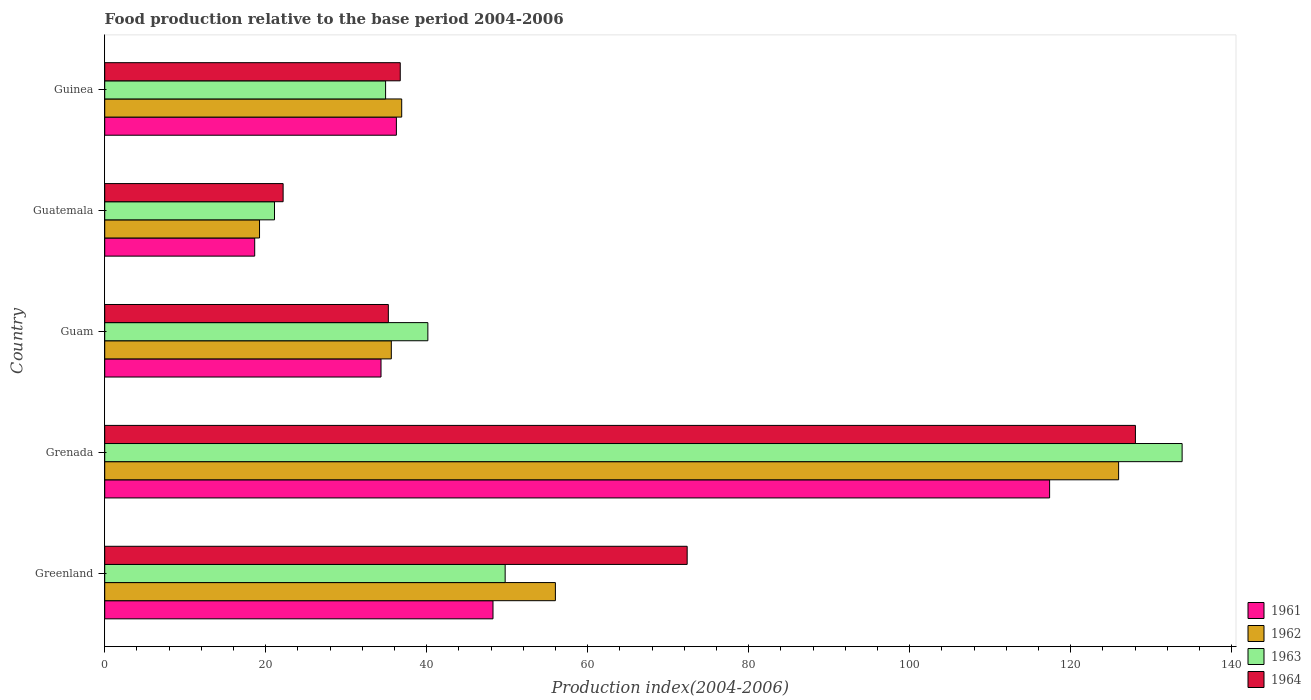How many different coloured bars are there?
Your response must be concise. 4. Are the number of bars per tick equal to the number of legend labels?
Your response must be concise. Yes. Are the number of bars on each tick of the Y-axis equal?
Your response must be concise. Yes. What is the label of the 1st group of bars from the top?
Your response must be concise. Guinea. What is the food production index in 1962 in Greenland?
Your answer should be very brief. 55.98. Across all countries, what is the maximum food production index in 1964?
Offer a terse response. 128.03. Across all countries, what is the minimum food production index in 1961?
Ensure brevity in your answer.  18.63. In which country was the food production index in 1962 maximum?
Make the answer very short. Grenada. In which country was the food production index in 1964 minimum?
Keep it short and to the point. Guatemala. What is the total food production index in 1964 in the graph?
Give a very brief answer. 294.48. What is the difference between the food production index in 1961 in Grenada and that in Guatemala?
Provide a succinct answer. 98.74. What is the difference between the food production index in 1961 in Greenland and the food production index in 1963 in Guam?
Give a very brief answer. 8.09. What is the average food production index in 1963 per country?
Ensure brevity in your answer.  55.94. What is the difference between the food production index in 1964 and food production index in 1962 in Grenada?
Ensure brevity in your answer.  2.09. What is the ratio of the food production index in 1964 in Grenada to that in Guam?
Your response must be concise. 3.63. Is the food production index in 1963 in Guam less than that in Guatemala?
Your answer should be compact. No. What is the difference between the highest and the second highest food production index in 1963?
Your answer should be very brief. 84.09. What is the difference between the highest and the lowest food production index in 1962?
Keep it short and to the point. 106.71. Is it the case that in every country, the sum of the food production index in 1964 and food production index in 1963 is greater than the sum of food production index in 1962 and food production index in 1961?
Your answer should be compact. No. What does the 2nd bar from the top in Grenada represents?
Keep it short and to the point. 1963. How many bars are there?
Provide a succinct answer. 20. How many countries are there in the graph?
Keep it short and to the point. 5. What is the difference between two consecutive major ticks on the X-axis?
Provide a succinct answer. 20. Are the values on the major ticks of X-axis written in scientific E-notation?
Give a very brief answer. No. Does the graph contain any zero values?
Offer a very short reply. No. Where does the legend appear in the graph?
Offer a terse response. Bottom right. What is the title of the graph?
Offer a terse response. Food production relative to the base period 2004-2006. What is the label or title of the X-axis?
Provide a succinct answer. Production index(2004-2006). What is the Production index(2004-2006) of 1961 in Greenland?
Offer a terse response. 48.23. What is the Production index(2004-2006) of 1962 in Greenland?
Your answer should be compact. 55.98. What is the Production index(2004-2006) in 1963 in Greenland?
Your answer should be very brief. 49.74. What is the Production index(2004-2006) of 1964 in Greenland?
Make the answer very short. 72.35. What is the Production index(2004-2006) in 1961 in Grenada?
Offer a terse response. 117.37. What is the Production index(2004-2006) in 1962 in Grenada?
Your answer should be very brief. 125.94. What is the Production index(2004-2006) of 1963 in Grenada?
Your answer should be very brief. 133.83. What is the Production index(2004-2006) in 1964 in Grenada?
Your response must be concise. 128.03. What is the Production index(2004-2006) of 1961 in Guam?
Provide a short and direct response. 34.32. What is the Production index(2004-2006) in 1962 in Guam?
Your answer should be very brief. 35.6. What is the Production index(2004-2006) of 1963 in Guam?
Your answer should be very brief. 40.14. What is the Production index(2004-2006) in 1964 in Guam?
Make the answer very short. 35.23. What is the Production index(2004-2006) of 1961 in Guatemala?
Provide a succinct answer. 18.63. What is the Production index(2004-2006) of 1962 in Guatemala?
Offer a very short reply. 19.23. What is the Production index(2004-2006) in 1963 in Guatemala?
Ensure brevity in your answer.  21.09. What is the Production index(2004-2006) of 1964 in Guatemala?
Offer a very short reply. 22.16. What is the Production index(2004-2006) in 1961 in Guinea?
Your answer should be compact. 36.23. What is the Production index(2004-2006) of 1962 in Guinea?
Your answer should be very brief. 36.89. What is the Production index(2004-2006) of 1963 in Guinea?
Provide a short and direct response. 34.89. What is the Production index(2004-2006) in 1964 in Guinea?
Your answer should be very brief. 36.71. Across all countries, what is the maximum Production index(2004-2006) in 1961?
Provide a succinct answer. 117.37. Across all countries, what is the maximum Production index(2004-2006) of 1962?
Keep it short and to the point. 125.94. Across all countries, what is the maximum Production index(2004-2006) in 1963?
Provide a short and direct response. 133.83. Across all countries, what is the maximum Production index(2004-2006) of 1964?
Keep it short and to the point. 128.03. Across all countries, what is the minimum Production index(2004-2006) of 1961?
Offer a very short reply. 18.63. Across all countries, what is the minimum Production index(2004-2006) in 1962?
Keep it short and to the point. 19.23. Across all countries, what is the minimum Production index(2004-2006) in 1963?
Your response must be concise. 21.09. Across all countries, what is the minimum Production index(2004-2006) of 1964?
Keep it short and to the point. 22.16. What is the total Production index(2004-2006) of 1961 in the graph?
Make the answer very short. 254.78. What is the total Production index(2004-2006) in 1962 in the graph?
Keep it short and to the point. 273.64. What is the total Production index(2004-2006) in 1963 in the graph?
Your answer should be very brief. 279.69. What is the total Production index(2004-2006) of 1964 in the graph?
Give a very brief answer. 294.48. What is the difference between the Production index(2004-2006) of 1961 in Greenland and that in Grenada?
Keep it short and to the point. -69.14. What is the difference between the Production index(2004-2006) in 1962 in Greenland and that in Grenada?
Offer a terse response. -69.96. What is the difference between the Production index(2004-2006) in 1963 in Greenland and that in Grenada?
Offer a terse response. -84.09. What is the difference between the Production index(2004-2006) of 1964 in Greenland and that in Grenada?
Offer a very short reply. -55.68. What is the difference between the Production index(2004-2006) of 1961 in Greenland and that in Guam?
Ensure brevity in your answer.  13.91. What is the difference between the Production index(2004-2006) of 1962 in Greenland and that in Guam?
Give a very brief answer. 20.38. What is the difference between the Production index(2004-2006) in 1964 in Greenland and that in Guam?
Make the answer very short. 37.12. What is the difference between the Production index(2004-2006) in 1961 in Greenland and that in Guatemala?
Your answer should be very brief. 29.6. What is the difference between the Production index(2004-2006) in 1962 in Greenland and that in Guatemala?
Ensure brevity in your answer.  36.75. What is the difference between the Production index(2004-2006) in 1963 in Greenland and that in Guatemala?
Make the answer very short. 28.65. What is the difference between the Production index(2004-2006) in 1964 in Greenland and that in Guatemala?
Give a very brief answer. 50.19. What is the difference between the Production index(2004-2006) in 1962 in Greenland and that in Guinea?
Offer a very short reply. 19.09. What is the difference between the Production index(2004-2006) of 1963 in Greenland and that in Guinea?
Offer a terse response. 14.85. What is the difference between the Production index(2004-2006) of 1964 in Greenland and that in Guinea?
Make the answer very short. 35.64. What is the difference between the Production index(2004-2006) of 1961 in Grenada and that in Guam?
Your response must be concise. 83.05. What is the difference between the Production index(2004-2006) of 1962 in Grenada and that in Guam?
Ensure brevity in your answer.  90.34. What is the difference between the Production index(2004-2006) in 1963 in Grenada and that in Guam?
Make the answer very short. 93.69. What is the difference between the Production index(2004-2006) of 1964 in Grenada and that in Guam?
Ensure brevity in your answer.  92.8. What is the difference between the Production index(2004-2006) in 1961 in Grenada and that in Guatemala?
Offer a terse response. 98.74. What is the difference between the Production index(2004-2006) of 1962 in Grenada and that in Guatemala?
Your answer should be very brief. 106.71. What is the difference between the Production index(2004-2006) in 1963 in Grenada and that in Guatemala?
Your answer should be compact. 112.74. What is the difference between the Production index(2004-2006) in 1964 in Grenada and that in Guatemala?
Give a very brief answer. 105.87. What is the difference between the Production index(2004-2006) of 1961 in Grenada and that in Guinea?
Give a very brief answer. 81.14. What is the difference between the Production index(2004-2006) of 1962 in Grenada and that in Guinea?
Keep it short and to the point. 89.05. What is the difference between the Production index(2004-2006) in 1963 in Grenada and that in Guinea?
Your answer should be very brief. 98.94. What is the difference between the Production index(2004-2006) in 1964 in Grenada and that in Guinea?
Offer a terse response. 91.32. What is the difference between the Production index(2004-2006) in 1961 in Guam and that in Guatemala?
Make the answer very short. 15.69. What is the difference between the Production index(2004-2006) in 1962 in Guam and that in Guatemala?
Make the answer very short. 16.37. What is the difference between the Production index(2004-2006) in 1963 in Guam and that in Guatemala?
Your response must be concise. 19.05. What is the difference between the Production index(2004-2006) of 1964 in Guam and that in Guatemala?
Give a very brief answer. 13.07. What is the difference between the Production index(2004-2006) in 1961 in Guam and that in Guinea?
Offer a terse response. -1.91. What is the difference between the Production index(2004-2006) in 1962 in Guam and that in Guinea?
Provide a short and direct response. -1.29. What is the difference between the Production index(2004-2006) of 1963 in Guam and that in Guinea?
Provide a succinct answer. 5.25. What is the difference between the Production index(2004-2006) of 1964 in Guam and that in Guinea?
Provide a short and direct response. -1.48. What is the difference between the Production index(2004-2006) in 1961 in Guatemala and that in Guinea?
Give a very brief answer. -17.6. What is the difference between the Production index(2004-2006) in 1962 in Guatemala and that in Guinea?
Provide a short and direct response. -17.66. What is the difference between the Production index(2004-2006) of 1963 in Guatemala and that in Guinea?
Ensure brevity in your answer.  -13.8. What is the difference between the Production index(2004-2006) of 1964 in Guatemala and that in Guinea?
Your response must be concise. -14.55. What is the difference between the Production index(2004-2006) in 1961 in Greenland and the Production index(2004-2006) in 1962 in Grenada?
Your answer should be compact. -77.71. What is the difference between the Production index(2004-2006) of 1961 in Greenland and the Production index(2004-2006) of 1963 in Grenada?
Offer a very short reply. -85.6. What is the difference between the Production index(2004-2006) in 1961 in Greenland and the Production index(2004-2006) in 1964 in Grenada?
Provide a succinct answer. -79.8. What is the difference between the Production index(2004-2006) of 1962 in Greenland and the Production index(2004-2006) of 1963 in Grenada?
Ensure brevity in your answer.  -77.85. What is the difference between the Production index(2004-2006) of 1962 in Greenland and the Production index(2004-2006) of 1964 in Grenada?
Offer a terse response. -72.05. What is the difference between the Production index(2004-2006) of 1963 in Greenland and the Production index(2004-2006) of 1964 in Grenada?
Ensure brevity in your answer.  -78.29. What is the difference between the Production index(2004-2006) in 1961 in Greenland and the Production index(2004-2006) in 1962 in Guam?
Provide a succinct answer. 12.63. What is the difference between the Production index(2004-2006) in 1961 in Greenland and the Production index(2004-2006) in 1963 in Guam?
Your answer should be very brief. 8.09. What is the difference between the Production index(2004-2006) of 1961 in Greenland and the Production index(2004-2006) of 1964 in Guam?
Your answer should be compact. 13. What is the difference between the Production index(2004-2006) in 1962 in Greenland and the Production index(2004-2006) in 1963 in Guam?
Provide a succinct answer. 15.84. What is the difference between the Production index(2004-2006) of 1962 in Greenland and the Production index(2004-2006) of 1964 in Guam?
Provide a short and direct response. 20.75. What is the difference between the Production index(2004-2006) in 1963 in Greenland and the Production index(2004-2006) in 1964 in Guam?
Provide a short and direct response. 14.51. What is the difference between the Production index(2004-2006) of 1961 in Greenland and the Production index(2004-2006) of 1962 in Guatemala?
Your answer should be compact. 29. What is the difference between the Production index(2004-2006) of 1961 in Greenland and the Production index(2004-2006) of 1963 in Guatemala?
Keep it short and to the point. 27.14. What is the difference between the Production index(2004-2006) of 1961 in Greenland and the Production index(2004-2006) of 1964 in Guatemala?
Make the answer very short. 26.07. What is the difference between the Production index(2004-2006) in 1962 in Greenland and the Production index(2004-2006) in 1963 in Guatemala?
Your response must be concise. 34.89. What is the difference between the Production index(2004-2006) in 1962 in Greenland and the Production index(2004-2006) in 1964 in Guatemala?
Offer a very short reply. 33.82. What is the difference between the Production index(2004-2006) of 1963 in Greenland and the Production index(2004-2006) of 1964 in Guatemala?
Provide a succinct answer. 27.58. What is the difference between the Production index(2004-2006) of 1961 in Greenland and the Production index(2004-2006) of 1962 in Guinea?
Make the answer very short. 11.34. What is the difference between the Production index(2004-2006) in 1961 in Greenland and the Production index(2004-2006) in 1963 in Guinea?
Ensure brevity in your answer.  13.34. What is the difference between the Production index(2004-2006) of 1961 in Greenland and the Production index(2004-2006) of 1964 in Guinea?
Provide a succinct answer. 11.52. What is the difference between the Production index(2004-2006) in 1962 in Greenland and the Production index(2004-2006) in 1963 in Guinea?
Ensure brevity in your answer.  21.09. What is the difference between the Production index(2004-2006) of 1962 in Greenland and the Production index(2004-2006) of 1964 in Guinea?
Provide a succinct answer. 19.27. What is the difference between the Production index(2004-2006) in 1963 in Greenland and the Production index(2004-2006) in 1964 in Guinea?
Make the answer very short. 13.03. What is the difference between the Production index(2004-2006) in 1961 in Grenada and the Production index(2004-2006) in 1962 in Guam?
Your response must be concise. 81.77. What is the difference between the Production index(2004-2006) in 1961 in Grenada and the Production index(2004-2006) in 1963 in Guam?
Ensure brevity in your answer.  77.23. What is the difference between the Production index(2004-2006) of 1961 in Grenada and the Production index(2004-2006) of 1964 in Guam?
Provide a short and direct response. 82.14. What is the difference between the Production index(2004-2006) of 1962 in Grenada and the Production index(2004-2006) of 1963 in Guam?
Your response must be concise. 85.8. What is the difference between the Production index(2004-2006) of 1962 in Grenada and the Production index(2004-2006) of 1964 in Guam?
Your response must be concise. 90.71. What is the difference between the Production index(2004-2006) in 1963 in Grenada and the Production index(2004-2006) in 1964 in Guam?
Keep it short and to the point. 98.6. What is the difference between the Production index(2004-2006) in 1961 in Grenada and the Production index(2004-2006) in 1962 in Guatemala?
Your answer should be very brief. 98.14. What is the difference between the Production index(2004-2006) of 1961 in Grenada and the Production index(2004-2006) of 1963 in Guatemala?
Provide a succinct answer. 96.28. What is the difference between the Production index(2004-2006) in 1961 in Grenada and the Production index(2004-2006) in 1964 in Guatemala?
Provide a succinct answer. 95.21. What is the difference between the Production index(2004-2006) in 1962 in Grenada and the Production index(2004-2006) in 1963 in Guatemala?
Your answer should be very brief. 104.85. What is the difference between the Production index(2004-2006) in 1962 in Grenada and the Production index(2004-2006) in 1964 in Guatemala?
Your response must be concise. 103.78. What is the difference between the Production index(2004-2006) in 1963 in Grenada and the Production index(2004-2006) in 1964 in Guatemala?
Your response must be concise. 111.67. What is the difference between the Production index(2004-2006) of 1961 in Grenada and the Production index(2004-2006) of 1962 in Guinea?
Keep it short and to the point. 80.48. What is the difference between the Production index(2004-2006) of 1961 in Grenada and the Production index(2004-2006) of 1963 in Guinea?
Give a very brief answer. 82.48. What is the difference between the Production index(2004-2006) in 1961 in Grenada and the Production index(2004-2006) in 1964 in Guinea?
Make the answer very short. 80.66. What is the difference between the Production index(2004-2006) of 1962 in Grenada and the Production index(2004-2006) of 1963 in Guinea?
Keep it short and to the point. 91.05. What is the difference between the Production index(2004-2006) in 1962 in Grenada and the Production index(2004-2006) in 1964 in Guinea?
Provide a succinct answer. 89.23. What is the difference between the Production index(2004-2006) of 1963 in Grenada and the Production index(2004-2006) of 1964 in Guinea?
Make the answer very short. 97.12. What is the difference between the Production index(2004-2006) in 1961 in Guam and the Production index(2004-2006) in 1962 in Guatemala?
Give a very brief answer. 15.09. What is the difference between the Production index(2004-2006) of 1961 in Guam and the Production index(2004-2006) of 1963 in Guatemala?
Keep it short and to the point. 13.23. What is the difference between the Production index(2004-2006) in 1961 in Guam and the Production index(2004-2006) in 1964 in Guatemala?
Offer a very short reply. 12.16. What is the difference between the Production index(2004-2006) in 1962 in Guam and the Production index(2004-2006) in 1963 in Guatemala?
Your response must be concise. 14.51. What is the difference between the Production index(2004-2006) of 1962 in Guam and the Production index(2004-2006) of 1964 in Guatemala?
Give a very brief answer. 13.44. What is the difference between the Production index(2004-2006) in 1963 in Guam and the Production index(2004-2006) in 1964 in Guatemala?
Provide a succinct answer. 17.98. What is the difference between the Production index(2004-2006) in 1961 in Guam and the Production index(2004-2006) in 1962 in Guinea?
Provide a short and direct response. -2.57. What is the difference between the Production index(2004-2006) in 1961 in Guam and the Production index(2004-2006) in 1963 in Guinea?
Give a very brief answer. -0.57. What is the difference between the Production index(2004-2006) in 1961 in Guam and the Production index(2004-2006) in 1964 in Guinea?
Offer a terse response. -2.39. What is the difference between the Production index(2004-2006) of 1962 in Guam and the Production index(2004-2006) of 1963 in Guinea?
Your response must be concise. 0.71. What is the difference between the Production index(2004-2006) in 1962 in Guam and the Production index(2004-2006) in 1964 in Guinea?
Keep it short and to the point. -1.11. What is the difference between the Production index(2004-2006) in 1963 in Guam and the Production index(2004-2006) in 1964 in Guinea?
Your answer should be compact. 3.43. What is the difference between the Production index(2004-2006) of 1961 in Guatemala and the Production index(2004-2006) of 1962 in Guinea?
Keep it short and to the point. -18.26. What is the difference between the Production index(2004-2006) of 1961 in Guatemala and the Production index(2004-2006) of 1963 in Guinea?
Keep it short and to the point. -16.26. What is the difference between the Production index(2004-2006) in 1961 in Guatemala and the Production index(2004-2006) in 1964 in Guinea?
Ensure brevity in your answer.  -18.08. What is the difference between the Production index(2004-2006) in 1962 in Guatemala and the Production index(2004-2006) in 1963 in Guinea?
Your answer should be very brief. -15.66. What is the difference between the Production index(2004-2006) in 1962 in Guatemala and the Production index(2004-2006) in 1964 in Guinea?
Make the answer very short. -17.48. What is the difference between the Production index(2004-2006) in 1963 in Guatemala and the Production index(2004-2006) in 1964 in Guinea?
Provide a short and direct response. -15.62. What is the average Production index(2004-2006) in 1961 per country?
Provide a succinct answer. 50.96. What is the average Production index(2004-2006) of 1962 per country?
Your answer should be compact. 54.73. What is the average Production index(2004-2006) in 1963 per country?
Your response must be concise. 55.94. What is the average Production index(2004-2006) in 1964 per country?
Ensure brevity in your answer.  58.9. What is the difference between the Production index(2004-2006) of 1961 and Production index(2004-2006) of 1962 in Greenland?
Ensure brevity in your answer.  -7.75. What is the difference between the Production index(2004-2006) in 1961 and Production index(2004-2006) in 1963 in Greenland?
Your answer should be very brief. -1.51. What is the difference between the Production index(2004-2006) of 1961 and Production index(2004-2006) of 1964 in Greenland?
Provide a succinct answer. -24.12. What is the difference between the Production index(2004-2006) in 1962 and Production index(2004-2006) in 1963 in Greenland?
Your answer should be compact. 6.24. What is the difference between the Production index(2004-2006) in 1962 and Production index(2004-2006) in 1964 in Greenland?
Ensure brevity in your answer.  -16.37. What is the difference between the Production index(2004-2006) of 1963 and Production index(2004-2006) of 1964 in Greenland?
Keep it short and to the point. -22.61. What is the difference between the Production index(2004-2006) of 1961 and Production index(2004-2006) of 1962 in Grenada?
Your answer should be very brief. -8.57. What is the difference between the Production index(2004-2006) of 1961 and Production index(2004-2006) of 1963 in Grenada?
Offer a very short reply. -16.46. What is the difference between the Production index(2004-2006) in 1961 and Production index(2004-2006) in 1964 in Grenada?
Keep it short and to the point. -10.66. What is the difference between the Production index(2004-2006) in 1962 and Production index(2004-2006) in 1963 in Grenada?
Your answer should be compact. -7.89. What is the difference between the Production index(2004-2006) in 1962 and Production index(2004-2006) in 1964 in Grenada?
Ensure brevity in your answer.  -2.09. What is the difference between the Production index(2004-2006) in 1961 and Production index(2004-2006) in 1962 in Guam?
Offer a very short reply. -1.28. What is the difference between the Production index(2004-2006) in 1961 and Production index(2004-2006) in 1963 in Guam?
Make the answer very short. -5.82. What is the difference between the Production index(2004-2006) of 1961 and Production index(2004-2006) of 1964 in Guam?
Your answer should be compact. -0.91. What is the difference between the Production index(2004-2006) in 1962 and Production index(2004-2006) in 1963 in Guam?
Provide a succinct answer. -4.54. What is the difference between the Production index(2004-2006) of 1962 and Production index(2004-2006) of 1964 in Guam?
Provide a short and direct response. 0.37. What is the difference between the Production index(2004-2006) of 1963 and Production index(2004-2006) of 1964 in Guam?
Offer a very short reply. 4.91. What is the difference between the Production index(2004-2006) in 1961 and Production index(2004-2006) in 1963 in Guatemala?
Provide a succinct answer. -2.46. What is the difference between the Production index(2004-2006) in 1961 and Production index(2004-2006) in 1964 in Guatemala?
Offer a terse response. -3.53. What is the difference between the Production index(2004-2006) of 1962 and Production index(2004-2006) of 1963 in Guatemala?
Keep it short and to the point. -1.86. What is the difference between the Production index(2004-2006) in 1962 and Production index(2004-2006) in 1964 in Guatemala?
Keep it short and to the point. -2.93. What is the difference between the Production index(2004-2006) in 1963 and Production index(2004-2006) in 1964 in Guatemala?
Offer a very short reply. -1.07. What is the difference between the Production index(2004-2006) of 1961 and Production index(2004-2006) of 1962 in Guinea?
Your answer should be compact. -0.66. What is the difference between the Production index(2004-2006) in 1961 and Production index(2004-2006) in 1963 in Guinea?
Offer a very short reply. 1.34. What is the difference between the Production index(2004-2006) of 1961 and Production index(2004-2006) of 1964 in Guinea?
Provide a short and direct response. -0.48. What is the difference between the Production index(2004-2006) in 1962 and Production index(2004-2006) in 1964 in Guinea?
Provide a short and direct response. 0.18. What is the difference between the Production index(2004-2006) in 1963 and Production index(2004-2006) in 1964 in Guinea?
Provide a succinct answer. -1.82. What is the ratio of the Production index(2004-2006) of 1961 in Greenland to that in Grenada?
Your answer should be compact. 0.41. What is the ratio of the Production index(2004-2006) of 1962 in Greenland to that in Grenada?
Your answer should be very brief. 0.44. What is the ratio of the Production index(2004-2006) of 1963 in Greenland to that in Grenada?
Your answer should be very brief. 0.37. What is the ratio of the Production index(2004-2006) in 1964 in Greenland to that in Grenada?
Your answer should be very brief. 0.57. What is the ratio of the Production index(2004-2006) of 1961 in Greenland to that in Guam?
Offer a very short reply. 1.41. What is the ratio of the Production index(2004-2006) in 1962 in Greenland to that in Guam?
Provide a succinct answer. 1.57. What is the ratio of the Production index(2004-2006) in 1963 in Greenland to that in Guam?
Your response must be concise. 1.24. What is the ratio of the Production index(2004-2006) of 1964 in Greenland to that in Guam?
Your response must be concise. 2.05. What is the ratio of the Production index(2004-2006) of 1961 in Greenland to that in Guatemala?
Your answer should be compact. 2.59. What is the ratio of the Production index(2004-2006) of 1962 in Greenland to that in Guatemala?
Your answer should be compact. 2.91. What is the ratio of the Production index(2004-2006) of 1963 in Greenland to that in Guatemala?
Ensure brevity in your answer.  2.36. What is the ratio of the Production index(2004-2006) of 1964 in Greenland to that in Guatemala?
Ensure brevity in your answer.  3.26. What is the ratio of the Production index(2004-2006) of 1961 in Greenland to that in Guinea?
Make the answer very short. 1.33. What is the ratio of the Production index(2004-2006) of 1962 in Greenland to that in Guinea?
Your response must be concise. 1.52. What is the ratio of the Production index(2004-2006) of 1963 in Greenland to that in Guinea?
Offer a terse response. 1.43. What is the ratio of the Production index(2004-2006) of 1964 in Greenland to that in Guinea?
Provide a succinct answer. 1.97. What is the ratio of the Production index(2004-2006) in 1961 in Grenada to that in Guam?
Provide a short and direct response. 3.42. What is the ratio of the Production index(2004-2006) in 1962 in Grenada to that in Guam?
Offer a very short reply. 3.54. What is the ratio of the Production index(2004-2006) in 1963 in Grenada to that in Guam?
Offer a terse response. 3.33. What is the ratio of the Production index(2004-2006) of 1964 in Grenada to that in Guam?
Make the answer very short. 3.63. What is the ratio of the Production index(2004-2006) in 1961 in Grenada to that in Guatemala?
Offer a terse response. 6.3. What is the ratio of the Production index(2004-2006) of 1962 in Grenada to that in Guatemala?
Make the answer very short. 6.55. What is the ratio of the Production index(2004-2006) in 1963 in Grenada to that in Guatemala?
Your answer should be very brief. 6.35. What is the ratio of the Production index(2004-2006) in 1964 in Grenada to that in Guatemala?
Your answer should be very brief. 5.78. What is the ratio of the Production index(2004-2006) in 1961 in Grenada to that in Guinea?
Give a very brief answer. 3.24. What is the ratio of the Production index(2004-2006) in 1962 in Grenada to that in Guinea?
Offer a terse response. 3.41. What is the ratio of the Production index(2004-2006) in 1963 in Grenada to that in Guinea?
Your answer should be very brief. 3.84. What is the ratio of the Production index(2004-2006) in 1964 in Grenada to that in Guinea?
Provide a short and direct response. 3.49. What is the ratio of the Production index(2004-2006) in 1961 in Guam to that in Guatemala?
Provide a short and direct response. 1.84. What is the ratio of the Production index(2004-2006) of 1962 in Guam to that in Guatemala?
Your response must be concise. 1.85. What is the ratio of the Production index(2004-2006) of 1963 in Guam to that in Guatemala?
Ensure brevity in your answer.  1.9. What is the ratio of the Production index(2004-2006) in 1964 in Guam to that in Guatemala?
Offer a terse response. 1.59. What is the ratio of the Production index(2004-2006) in 1961 in Guam to that in Guinea?
Give a very brief answer. 0.95. What is the ratio of the Production index(2004-2006) of 1963 in Guam to that in Guinea?
Offer a very short reply. 1.15. What is the ratio of the Production index(2004-2006) in 1964 in Guam to that in Guinea?
Make the answer very short. 0.96. What is the ratio of the Production index(2004-2006) of 1961 in Guatemala to that in Guinea?
Make the answer very short. 0.51. What is the ratio of the Production index(2004-2006) of 1962 in Guatemala to that in Guinea?
Offer a terse response. 0.52. What is the ratio of the Production index(2004-2006) in 1963 in Guatemala to that in Guinea?
Offer a terse response. 0.6. What is the ratio of the Production index(2004-2006) in 1964 in Guatemala to that in Guinea?
Your answer should be compact. 0.6. What is the difference between the highest and the second highest Production index(2004-2006) of 1961?
Offer a terse response. 69.14. What is the difference between the highest and the second highest Production index(2004-2006) of 1962?
Give a very brief answer. 69.96. What is the difference between the highest and the second highest Production index(2004-2006) of 1963?
Your answer should be very brief. 84.09. What is the difference between the highest and the second highest Production index(2004-2006) of 1964?
Ensure brevity in your answer.  55.68. What is the difference between the highest and the lowest Production index(2004-2006) in 1961?
Your response must be concise. 98.74. What is the difference between the highest and the lowest Production index(2004-2006) of 1962?
Your answer should be very brief. 106.71. What is the difference between the highest and the lowest Production index(2004-2006) in 1963?
Keep it short and to the point. 112.74. What is the difference between the highest and the lowest Production index(2004-2006) of 1964?
Provide a short and direct response. 105.87. 